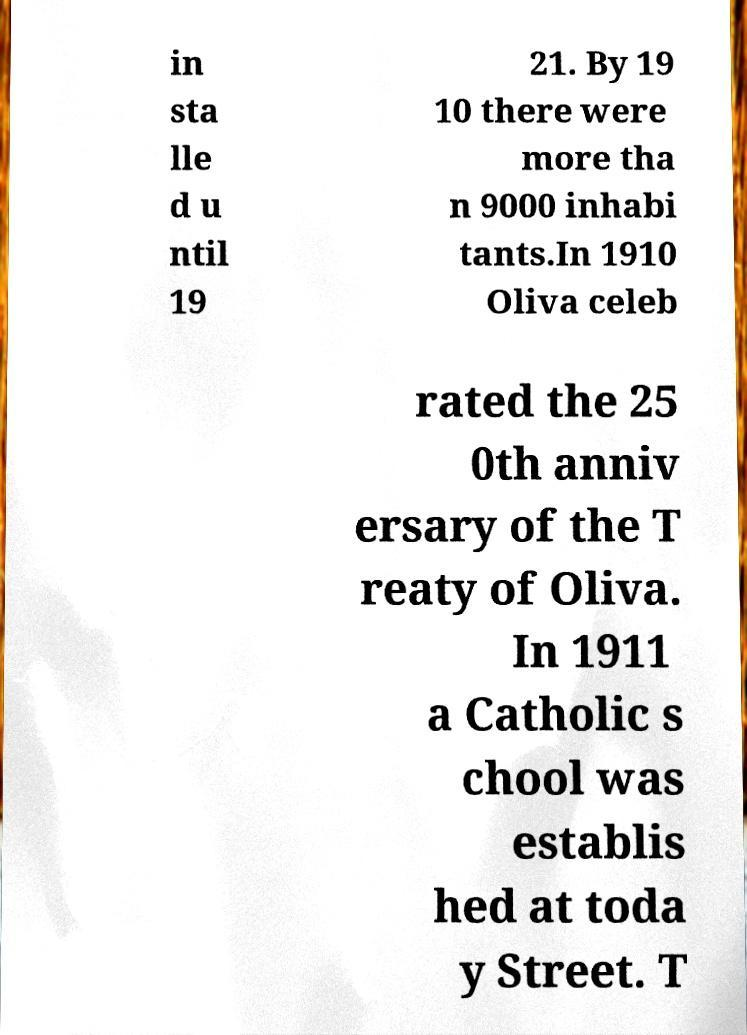For documentation purposes, I need the text within this image transcribed. Could you provide that? in sta lle d u ntil 19 21. By 19 10 there were more tha n 9000 inhabi tants.In 1910 Oliva celeb rated the 25 0th anniv ersary of the T reaty of Oliva. In 1911 a Catholic s chool was establis hed at toda y Street. T 